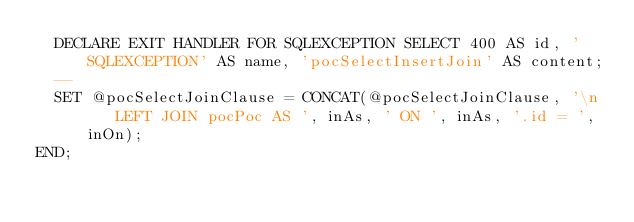<code> <loc_0><loc_0><loc_500><loc_500><_SQL_>  DECLARE EXIT HANDLER FOR SQLEXCEPTION SELECT 400 AS id, 'SQLEXCEPTION' AS name, 'pocSelectInsertJoin' AS content;
  --
  SET @pocSelectJoinClause = CONCAT(@pocSelectJoinClause, '\n    LEFT JOIN pocPoc AS ', inAs, ' ON ', inAs, '.id = ', inOn);
END;
</code> 